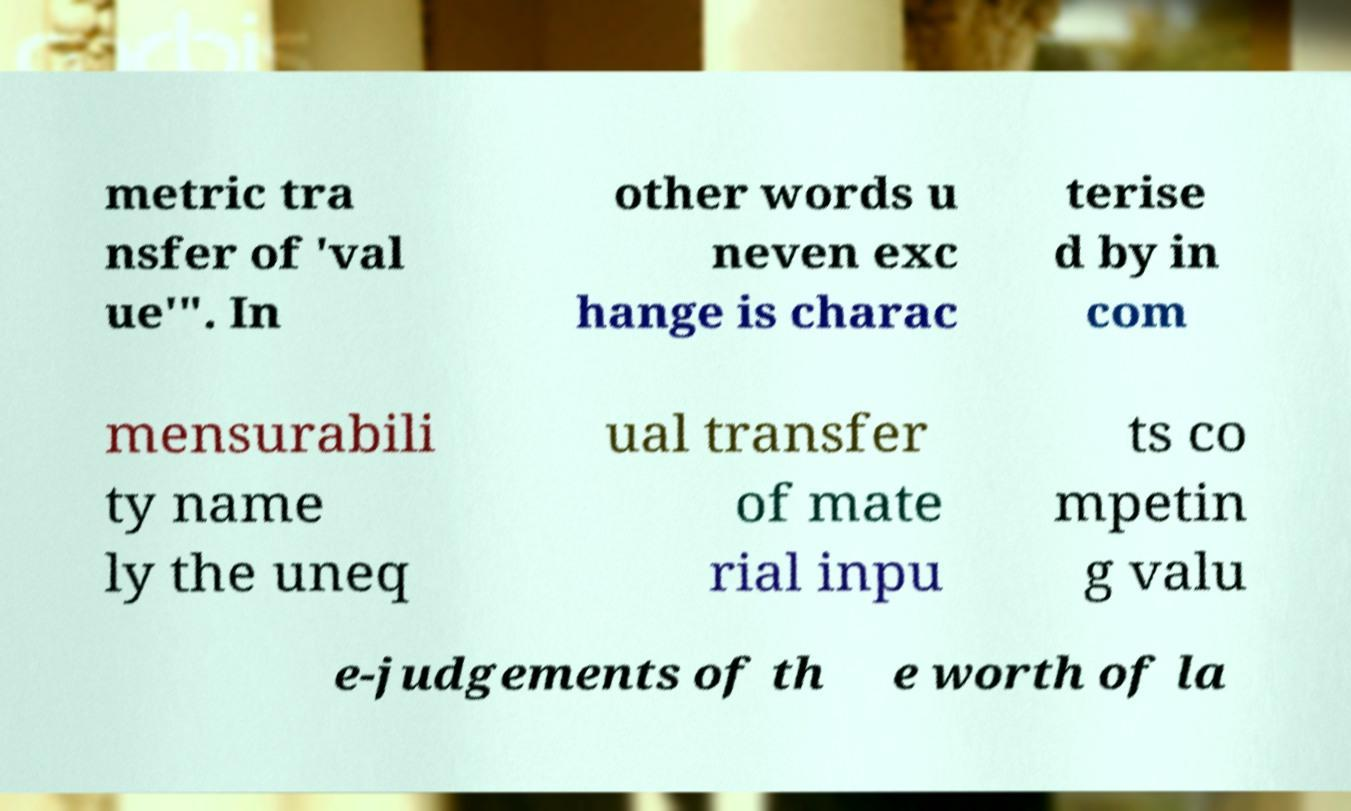Could you assist in decoding the text presented in this image and type it out clearly? metric tra nsfer of 'val ue'". In other words u neven exc hange is charac terise d by in com mensurabili ty name ly the uneq ual transfer of mate rial inpu ts co mpetin g valu e-judgements of th e worth of la 